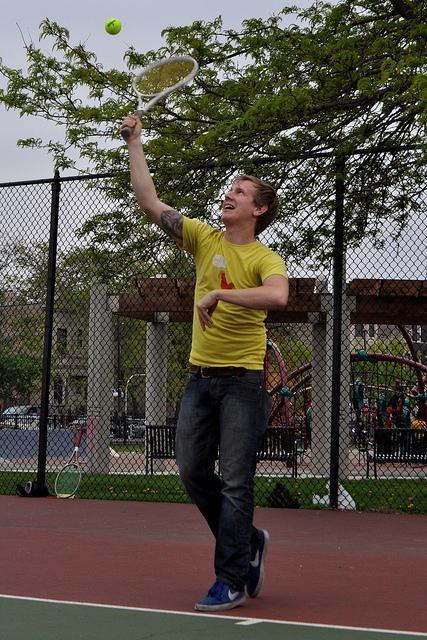How many slices of pizza are there?
Give a very brief answer. 0. 